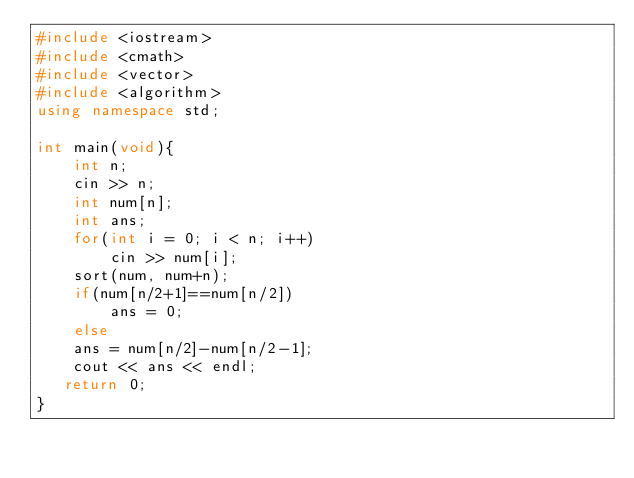<code> <loc_0><loc_0><loc_500><loc_500><_C++_>#include <iostream>
#include <cmath>
#include <vector>
#include <algorithm>
using namespace std;

int main(void){
    int n;
    cin >> n;
    int num[n];
    int ans;
    for(int i = 0; i < n; i++)
        cin >> num[i];
    sort(num, num+n);
    if(num[n/2+1]==num[n/2])
        ans = 0;
    else
    ans = num[n/2]-num[n/2-1];
    cout << ans << endl;
   return 0;
}</code> 